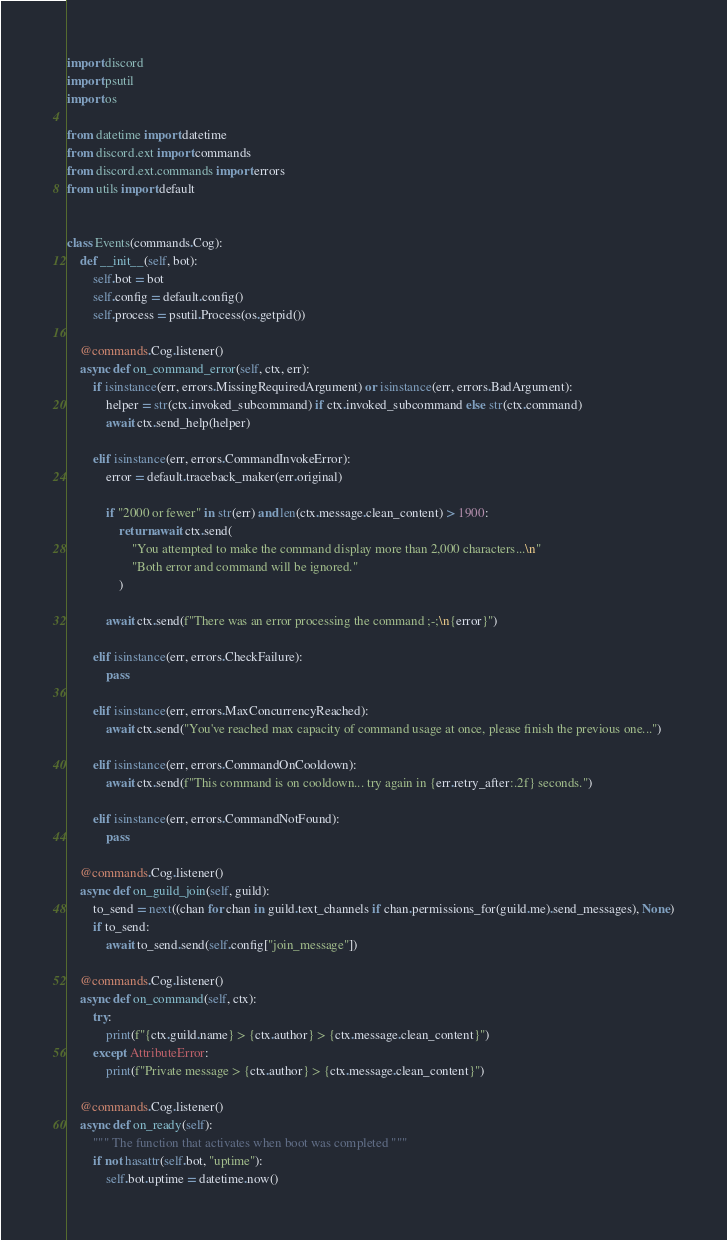Convert code to text. <code><loc_0><loc_0><loc_500><loc_500><_Python_>import discord
import psutil
import os

from datetime import datetime
from discord.ext import commands
from discord.ext.commands import errors
from utils import default


class Events(commands.Cog):
    def __init__(self, bot):
        self.bot = bot
        self.config = default.config()
        self.process = psutil.Process(os.getpid())

    @commands.Cog.listener()
    async def on_command_error(self, ctx, err):
        if isinstance(err, errors.MissingRequiredArgument) or isinstance(err, errors.BadArgument):
            helper = str(ctx.invoked_subcommand) if ctx.invoked_subcommand else str(ctx.command)
            await ctx.send_help(helper)

        elif isinstance(err, errors.CommandInvokeError):
            error = default.traceback_maker(err.original)

            if "2000 or fewer" in str(err) and len(ctx.message.clean_content) > 1900:
                return await ctx.send(
                    "You attempted to make the command display more than 2,000 characters...\n"
                    "Both error and command will be ignored."
                )

            await ctx.send(f"There was an error processing the command ;-;\n{error}")

        elif isinstance(err, errors.CheckFailure):
            pass

        elif isinstance(err, errors.MaxConcurrencyReached):
            await ctx.send("You've reached max capacity of command usage at once, please finish the previous one...")

        elif isinstance(err, errors.CommandOnCooldown):
            await ctx.send(f"This command is on cooldown... try again in {err.retry_after:.2f} seconds.")

        elif isinstance(err, errors.CommandNotFound):
            pass

    @commands.Cog.listener()
    async def on_guild_join(self, guild):
        to_send = next((chan for chan in guild.text_channels if chan.permissions_for(guild.me).send_messages), None)
        if to_send:
            await to_send.send(self.config["join_message"])

    @commands.Cog.listener()
    async def on_command(self, ctx):
        try:
            print(f"{ctx.guild.name} > {ctx.author} > {ctx.message.clean_content}")
        except AttributeError:
            print(f"Private message > {ctx.author} > {ctx.message.clean_content}")

    @commands.Cog.listener()
    async def on_ready(self):
        """ The function that activates when boot was completed """
        if not hasattr(self.bot, "uptime"):
            self.bot.uptime = datetime.now()
</code> 